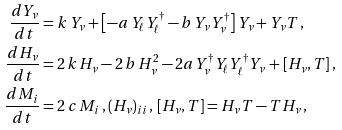<formula> <loc_0><loc_0><loc_500><loc_500>\frac { d Y _ { \nu } } { d t } & = k \, Y _ { \nu } + \left [ - a \, Y _ { \ell } Y _ { \ell } ^ { \dagger } - b \, Y _ { \nu } Y _ { \nu } ^ { \dagger } \right ] Y _ { \nu } + Y _ { \nu } T \, , \\ \frac { d H _ { \nu } } { d t } & = 2 \, k \, H _ { \nu } - 2 \, b \, H _ { \nu } ^ { 2 } - 2 a Y _ { \nu } ^ { \dag } Y _ { \ell } Y _ { \ell } ^ { \dag } Y _ { \nu } \, + [ H _ { \nu } , T ] \, , \\ \frac { d M _ { i } } { d t } & = 2 \, c \, M _ { i } \, , ( H _ { \nu } ) _ { i i } \, , \, [ H _ { \nu } , T ] = H _ { \nu } T - T H _ { \nu } \, ,</formula> 